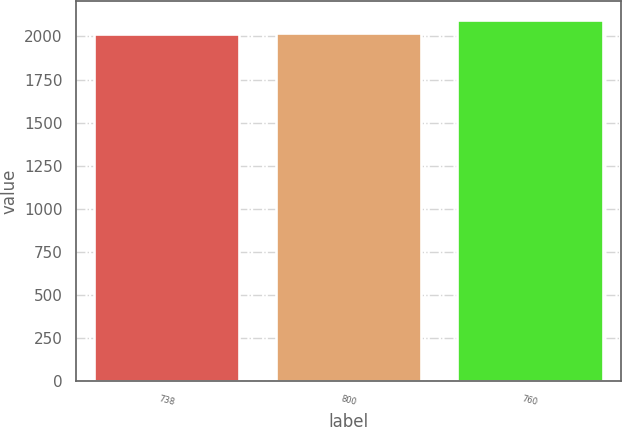Convert chart to OTSL. <chart><loc_0><loc_0><loc_500><loc_500><bar_chart><fcel>738<fcel>800<fcel>760<nl><fcel>2014<fcel>2022.4<fcel>2098<nl></chart> 